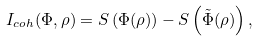Convert formula to latex. <formula><loc_0><loc_0><loc_500><loc_500>I _ { c o h } ( \Phi , \rho ) = S \left ( \Phi ( \rho ) \right ) - S \left ( \tilde { \Phi } ( \rho ) \right ) ,</formula> 